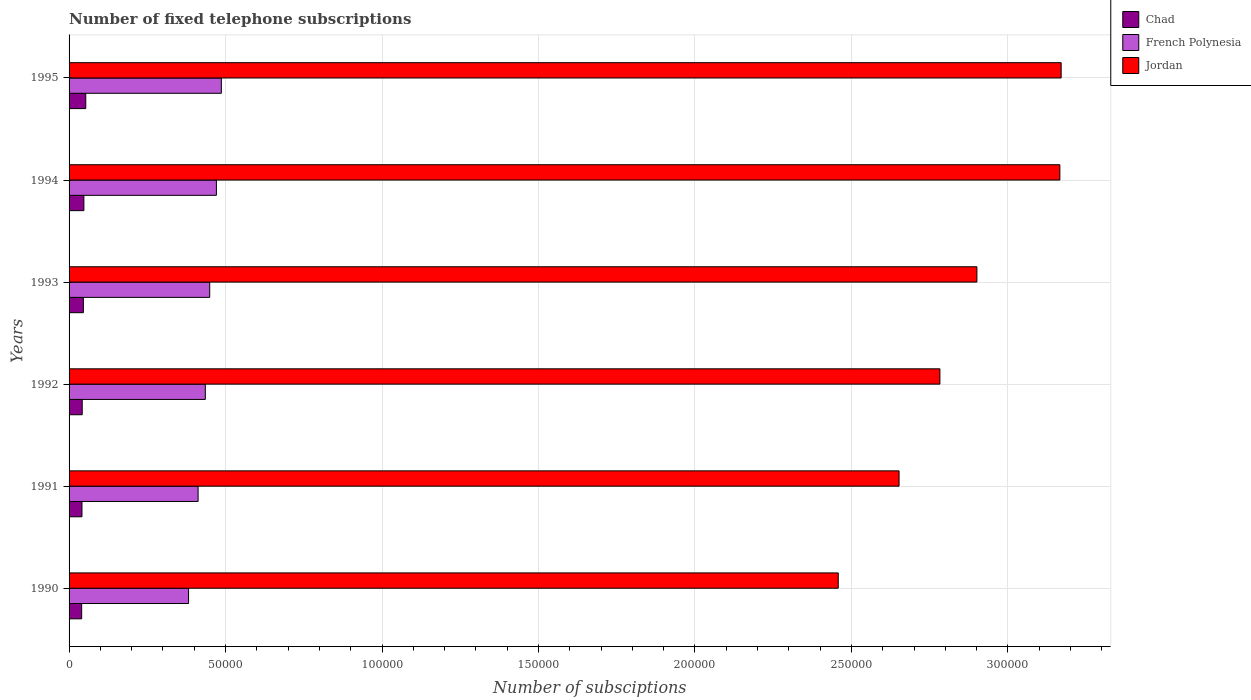Are the number of bars per tick equal to the number of legend labels?
Offer a terse response. Yes. In how many cases, is the number of bars for a given year not equal to the number of legend labels?
Your answer should be very brief. 0. What is the number of fixed telephone subscriptions in Jordan in 1991?
Your answer should be very brief. 2.65e+05. Across all years, what is the maximum number of fixed telephone subscriptions in Chad?
Keep it short and to the point. 5334. Across all years, what is the minimum number of fixed telephone subscriptions in French Polynesia?
Give a very brief answer. 3.82e+04. In which year was the number of fixed telephone subscriptions in French Polynesia maximum?
Give a very brief answer. 1995. What is the total number of fixed telephone subscriptions in French Polynesia in the graph?
Ensure brevity in your answer.  2.64e+05. What is the difference between the number of fixed telephone subscriptions in French Polynesia in 1993 and that in 1994?
Make the answer very short. -2135. What is the difference between the number of fixed telephone subscriptions in Jordan in 1992 and the number of fixed telephone subscriptions in French Polynesia in 1995?
Give a very brief answer. 2.30e+05. What is the average number of fixed telephone subscriptions in French Polynesia per year?
Give a very brief answer. 4.39e+04. In the year 1995, what is the difference between the number of fixed telephone subscriptions in Chad and number of fixed telephone subscriptions in Jordan?
Your answer should be compact. -3.12e+05. What is the ratio of the number of fixed telephone subscriptions in French Polynesia in 1990 to that in 1994?
Offer a very short reply. 0.81. Is the difference between the number of fixed telephone subscriptions in Chad in 1991 and 1993 greater than the difference between the number of fixed telephone subscriptions in Jordan in 1991 and 1993?
Ensure brevity in your answer.  Yes. What is the difference between the highest and the second highest number of fixed telephone subscriptions in Chad?
Offer a very short reply. 601. What is the difference between the highest and the lowest number of fixed telephone subscriptions in Jordan?
Keep it short and to the point. 7.12e+04. In how many years, is the number of fixed telephone subscriptions in French Polynesia greater than the average number of fixed telephone subscriptions in French Polynesia taken over all years?
Ensure brevity in your answer.  3. Is the sum of the number of fixed telephone subscriptions in Chad in 1991 and 1995 greater than the maximum number of fixed telephone subscriptions in French Polynesia across all years?
Keep it short and to the point. No. What does the 3rd bar from the top in 1995 represents?
Provide a short and direct response. Chad. What does the 1st bar from the bottom in 1995 represents?
Offer a very short reply. Chad. Is it the case that in every year, the sum of the number of fixed telephone subscriptions in Chad and number of fixed telephone subscriptions in Jordan is greater than the number of fixed telephone subscriptions in French Polynesia?
Your answer should be compact. Yes. How many bars are there?
Your answer should be very brief. 18. What is the difference between two consecutive major ticks on the X-axis?
Keep it short and to the point. 5.00e+04. Does the graph contain any zero values?
Offer a very short reply. No. What is the title of the graph?
Provide a short and direct response. Number of fixed telephone subscriptions. Does "Yemen, Rep." appear as one of the legend labels in the graph?
Your response must be concise. No. What is the label or title of the X-axis?
Give a very brief answer. Number of subsciptions. What is the label or title of the Y-axis?
Provide a succinct answer. Years. What is the Number of subsciptions of Chad in 1990?
Ensure brevity in your answer.  4026. What is the Number of subsciptions in French Polynesia in 1990?
Offer a very short reply. 3.82e+04. What is the Number of subsciptions in Jordan in 1990?
Offer a terse response. 2.46e+05. What is the Number of subsciptions of Chad in 1991?
Give a very brief answer. 4121. What is the Number of subsciptions in French Polynesia in 1991?
Ensure brevity in your answer.  4.12e+04. What is the Number of subsciptions in Jordan in 1991?
Your answer should be very brief. 2.65e+05. What is the Number of subsciptions of Chad in 1992?
Offer a very short reply. 4200. What is the Number of subsciptions of French Polynesia in 1992?
Keep it short and to the point. 4.35e+04. What is the Number of subsciptions in Jordan in 1992?
Make the answer very short. 2.78e+05. What is the Number of subsciptions of Chad in 1993?
Make the answer very short. 4571. What is the Number of subsciptions of French Polynesia in 1993?
Provide a short and direct response. 4.49e+04. What is the Number of subsciptions in Jordan in 1993?
Keep it short and to the point. 2.90e+05. What is the Number of subsciptions in Chad in 1994?
Your response must be concise. 4733. What is the Number of subsciptions in French Polynesia in 1994?
Offer a terse response. 4.71e+04. What is the Number of subsciptions of Jordan in 1994?
Your answer should be very brief. 3.17e+05. What is the Number of subsciptions in Chad in 1995?
Offer a terse response. 5334. What is the Number of subsciptions of French Polynesia in 1995?
Your answer should be very brief. 4.87e+04. What is the Number of subsciptions of Jordan in 1995?
Provide a short and direct response. 3.17e+05. Across all years, what is the maximum Number of subsciptions in Chad?
Keep it short and to the point. 5334. Across all years, what is the maximum Number of subsciptions of French Polynesia?
Give a very brief answer. 4.87e+04. Across all years, what is the maximum Number of subsciptions in Jordan?
Provide a short and direct response. 3.17e+05. Across all years, what is the minimum Number of subsciptions of Chad?
Give a very brief answer. 4026. Across all years, what is the minimum Number of subsciptions in French Polynesia?
Ensure brevity in your answer.  3.82e+04. Across all years, what is the minimum Number of subsciptions in Jordan?
Your answer should be compact. 2.46e+05. What is the total Number of subsciptions in Chad in the graph?
Your response must be concise. 2.70e+04. What is the total Number of subsciptions of French Polynesia in the graph?
Ensure brevity in your answer.  2.64e+05. What is the total Number of subsciptions of Jordan in the graph?
Make the answer very short. 1.71e+06. What is the difference between the Number of subsciptions in Chad in 1990 and that in 1991?
Offer a terse response. -95. What is the difference between the Number of subsciptions in French Polynesia in 1990 and that in 1991?
Your response must be concise. -3051. What is the difference between the Number of subsciptions of Jordan in 1990 and that in 1991?
Keep it short and to the point. -1.94e+04. What is the difference between the Number of subsciptions in Chad in 1990 and that in 1992?
Keep it short and to the point. -174. What is the difference between the Number of subsciptions of French Polynesia in 1990 and that in 1992?
Provide a succinct answer. -5359. What is the difference between the Number of subsciptions of Jordan in 1990 and that in 1992?
Your answer should be very brief. -3.25e+04. What is the difference between the Number of subsciptions in Chad in 1990 and that in 1993?
Your answer should be very brief. -545. What is the difference between the Number of subsciptions of French Polynesia in 1990 and that in 1993?
Provide a succinct answer. -6763. What is the difference between the Number of subsciptions of Jordan in 1990 and that in 1993?
Offer a terse response. -4.43e+04. What is the difference between the Number of subsciptions in Chad in 1990 and that in 1994?
Provide a short and direct response. -707. What is the difference between the Number of subsciptions in French Polynesia in 1990 and that in 1994?
Provide a succinct answer. -8898. What is the difference between the Number of subsciptions in Jordan in 1990 and that in 1994?
Offer a very short reply. -7.08e+04. What is the difference between the Number of subsciptions of Chad in 1990 and that in 1995?
Your response must be concise. -1308. What is the difference between the Number of subsciptions in French Polynesia in 1990 and that in 1995?
Provide a succinct answer. -1.05e+04. What is the difference between the Number of subsciptions of Jordan in 1990 and that in 1995?
Make the answer very short. -7.12e+04. What is the difference between the Number of subsciptions in Chad in 1991 and that in 1992?
Your response must be concise. -79. What is the difference between the Number of subsciptions of French Polynesia in 1991 and that in 1992?
Offer a terse response. -2308. What is the difference between the Number of subsciptions of Jordan in 1991 and that in 1992?
Provide a succinct answer. -1.31e+04. What is the difference between the Number of subsciptions of Chad in 1991 and that in 1993?
Your answer should be compact. -450. What is the difference between the Number of subsciptions of French Polynesia in 1991 and that in 1993?
Your answer should be compact. -3712. What is the difference between the Number of subsciptions of Jordan in 1991 and that in 1993?
Give a very brief answer. -2.49e+04. What is the difference between the Number of subsciptions of Chad in 1991 and that in 1994?
Provide a short and direct response. -612. What is the difference between the Number of subsciptions of French Polynesia in 1991 and that in 1994?
Give a very brief answer. -5847. What is the difference between the Number of subsciptions in Jordan in 1991 and that in 1994?
Ensure brevity in your answer.  -5.14e+04. What is the difference between the Number of subsciptions in Chad in 1991 and that in 1995?
Offer a terse response. -1213. What is the difference between the Number of subsciptions of French Polynesia in 1991 and that in 1995?
Ensure brevity in your answer.  -7424. What is the difference between the Number of subsciptions in Jordan in 1991 and that in 1995?
Offer a very short reply. -5.18e+04. What is the difference between the Number of subsciptions in Chad in 1992 and that in 1993?
Your answer should be very brief. -371. What is the difference between the Number of subsciptions of French Polynesia in 1992 and that in 1993?
Offer a terse response. -1404. What is the difference between the Number of subsciptions in Jordan in 1992 and that in 1993?
Offer a terse response. -1.18e+04. What is the difference between the Number of subsciptions in Chad in 1992 and that in 1994?
Offer a terse response. -533. What is the difference between the Number of subsciptions in French Polynesia in 1992 and that in 1994?
Your answer should be very brief. -3539. What is the difference between the Number of subsciptions in Jordan in 1992 and that in 1994?
Provide a short and direct response. -3.83e+04. What is the difference between the Number of subsciptions in Chad in 1992 and that in 1995?
Offer a terse response. -1134. What is the difference between the Number of subsciptions in French Polynesia in 1992 and that in 1995?
Keep it short and to the point. -5116. What is the difference between the Number of subsciptions in Jordan in 1992 and that in 1995?
Give a very brief answer. -3.87e+04. What is the difference between the Number of subsciptions in Chad in 1993 and that in 1994?
Your answer should be compact. -162. What is the difference between the Number of subsciptions of French Polynesia in 1993 and that in 1994?
Your answer should be very brief. -2135. What is the difference between the Number of subsciptions of Jordan in 1993 and that in 1994?
Your response must be concise. -2.65e+04. What is the difference between the Number of subsciptions of Chad in 1993 and that in 1995?
Ensure brevity in your answer.  -763. What is the difference between the Number of subsciptions in French Polynesia in 1993 and that in 1995?
Provide a succinct answer. -3712. What is the difference between the Number of subsciptions of Jordan in 1993 and that in 1995?
Your answer should be compact. -2.69e+04. What is the difference between the Number of subsciptions of Chad in 1994 and that in 1995?
Your response must be concise. -601. What is the difference between the Number of subsciptions in French Polynesia in 1994 and that in 1995?
Provide a short and direct response. -1577. What is the difference between the Number of subsciptions in Jordan in 1994 and that in 1995?
Your answer should be compact. -414. What is the difference between the Number of subsciptions in Chad in 1990 and the Number of subsciptions in French Polynesia in 1991?
Your answer should be very brief. -3.72e+04. What is the difference between the Number of subsciptions in Chad in 1990 and the Number of subsciptions in Jordan in 1991?
Offer a very short reply. -2.61e+05. What is the difference between the Number of subsciptions of French Polynesia in 1990 and the Number of subsciptions of Jordan in 1991?
Provide a short and direct response. -2.27e+05. What is the difference between the Number of subsciptions in Chad in 1990 and the Number of subsciptions in French Polynesia in 1992?
Offer a terse response. -3.95e+04. What is the difference between the Number of subsciptions in Chad in 1990 and the Number of subsciptions in Jordan in 1992?
Make the answer very short. -2.74e+05. What is the difference between the Number of subsciptions of French Polynesia in 1990 and the Number of subsciptions of Jordan in 1992?
Provide a short and direct response. -2.40e+05. What is the difference between the Number of subsciptions of Chad in 1990 and the Number of subsciptions of French Polynesia in 1993?
Provide a short and direct response. -4.09e+04. What is the difference between the Number of subsciptions of Chad in 1990 and the Number of subsciptions of Jordan in 1993?
Your answer should be compact. -2.86e+05. What is the difference between the Number of subsciptions in French Polynesia in 1990 and the Number of subsciptions in Jordan in 1993?
Provide a short and direct response. -2.52e+05. What is the difference between the Number of subsciptions in Chad in 1990 and the Number of subsciptions in French Polynesia in 1994?
Provide a short and direct response. -4.31e+04. What is the difference between the Number of subsciptions of Chad in 1990 and the Number of subsciptions of Jordan in 1994?
Your answer should be very brief. -3.13e+05. What is the difference between the Number of subsciptions in French Polynesia in 1990 and the Number of subsciptions in Jordan in 1994?
Provide a succinct answer. -2.78e+05. What is the difference between the Number of subsciptions of Chad in 1990 and the Number of subsciptions of French Polynesia in 1995?
Make the answer very short. -4.46e+04. What is the difference between the Number of subsciptions in Chad in 1990 and the Number of subsciptions in Jordan in 1995?
Your answer should be very brief. -3.13e+05. What is the difference between the Number of subsciptions of French Polynesia in 1990 and the Number of subsciptions of Jordan in 1995?
Ensure brevity in your answer.  -2.79e+05. What is the difference between the Number of subsciptions of Chad in 1991 and the Number of subsciptions of French Polynesia in 1992?
Give a very brief answer. -3.94e+04. What is the difference between the Number of subsciptions of Chad in 1991 and the Number of subsciptions of Jordan in 1992?
Provide a succinct answer. -2.74e+05. What is the difference between the Number of subsciptions in French Polynesia in 1991 and the Number of subsciptions in Jordan in 1992?
Keep it short and to the point. -2.37e+05. What is the difference between the Number of subsciptions of Chad in 1991 and the Number of subsciptions of French Polynesia in 1993?
Offer a very short reply. -4.08e+04. What is the difference between the Number of subsciptions in Chad in 1991 and the Number of subsciptions in Jordan in 1993?
Give a very brief answer. -2.86e+05. What is the difference between the Number of subsciptions in French Polynesia in 1991 and the Number of subsciptions in Jordan in 1993?
Your answer should be very brief. -2.49e+05. What is the difference between the Number of subsciptions in Chad in 1991 and the Number of subsciptions in French Polynesia in 1994?
Provide a succinct answer. -4.30e+04. What is the difference between the Number of subsciptions of Chad in 1991 and the Number of subsciptions of Jordan in 1994?
Ensure brevity in your answer.  -3.12e+05. What is the difference between the Number of subsciptions in French Polynesia in 1991 and the Number of subsciptions in Jordan in 1994?
Your answer should be very brief. -2.75e+05. What is the difference between the Number of subsciptions in Chad in 1991 and the Number of subsciptions in French Polynesia in 1995?
Provide a succinct answer. -4.45e+04. What is the difference between the Number of subsciptions of Chad in 1991 and the Number of subsciptions of Jordan in 1995?
Your response must be concise. -3.13e+05. What is the difference between the Number of subsciptions of French Polynesia in 1991 and the Number of subsciptions of Jordan in 1995?
Your response must be concise. -2.76e+05. What is the difference between the Number of subsciptions in Chad in 1992 and the Number of subsciptions in French Polynesia in 1993?
Your answer should be compact. -4.07e+04. What is the difference between the Number of subsciptions in Chad in 1992 and the Number of subsciptions in Jordan in 1993?
Offer a very short reply. -2.86e+05. What is the difference between the Number of subsciptions of French Polynesia in 1992 and the Number of subsciptions of Jordan in 1993?
Ensure brevity in your answer.  -2.47e+05. What is the difference between the Number of subsciptions in Chad in 1992 and the Number of subsciptions in French Polynesia in 1994?
Ensure brevity in your answer.  -4.29e+04. What is the difference between the Number of subsciptions of Chad in 1992 and the Number of subsciptions of Jordan in 1994?
Give a very brief answer. -3.12e+05. What is the difference between the Number of subsciptions of French Polynesia in 1992 and the Number of subsciptions of Jordan in 1994?
Offer a terse response. -2.73e+05. What is the difference between the Number of subsciptions of Chad in 1992 and the Number of subsciptions of French Polynesia in 1995?
Offer a very short reply. -4.45e+04. What is the difference between the Number of subsciptions in Chad in 1992 and the Number of subsciptions in Jordan in 1995?
Your answer should be very brief. -3.13e+05. What is the difference between the Number of subsciptions of French Polynesia in 1992 and the Number of subsciptions of Jordan in 1995?
Provide a succinct answer. -2.73e+05. What is the difference between the Number of subsciptions in Chad in 1993 and the Number of subsciptions in French Polynesia in 1994?
Your response must be concise. -4.25e+04. What is the difference between the Number of subsciptions of Chad in 1993 and the Number of subsciptions of Jordan in 1994?
Your answer should be very brief. -3.12e+05. What is the difference between the Number of subsciptions in French Polynesia in 1993 and the Number of subsciptions in Jordan in 1994?
Keep it short and to the point. -2.72e+05. What is the difference between the Number of subsciptions of Chad in 1993 and the Number of subsciptions of French Polynesia in 1995?
Offer a terse response. -4.41e+04. What is the difference between the Number of subsciptions of Chad in 1993 and the Number of subsciptions of Jordan in 1995?
Offer a terse response. -3.12e+05. What is the difference between the Number of subsciptions of French Polynesia in 1993 and the Number of subsciptions of Jordan in 1995?
Make the answer very short. -2.72e+05. What is the difference between the Number of subsciptions in Chad in 1994 and the Number of subsciptions in French Polynesia in 1995?
Your response must be concise. -4.39e+04. What is the difference between the Number of subsciptions of Chad in 1994 and the Number of subsciptions of Jordan in 1995?
Your answer should be compact. -3.12e+05. What is the difference between the Number of subsciptions of French Polynesia in 1994 and the Number of subsciptions of Jordan in 1995?
Keep it short and to the point. -2.70e+05. What is the average Number of subsciptions in Chad per year?
Give a very brief answer. 4497.5. What is the average Number of subsciptions of French Polynesia per year?
Ensure brevity in your answer.  4.39e+04. What is the average Number of subsciptions in Jordan per year?
Ensure brevity in your answer.  2.85e+05. In the year 1990, what is the difference between the Number of subsciptions in Chad and Number of subsciptions in French Polynesia?
Ensure brevity in your answer.  -3.42e+04. In the year 1990, what is the difference between the Number of subsciptions of Chad and Number of subsciptions of Jordan?
Provide a short and direct response. -2.42e+05. In the year 1990, what is the difference between the Number of subsciptions of French Polynesia and Number of subsciptions of Jordan?
Provide a succinct answer. -2.08e+05. In the year 1991, what is the difference between the Number of subsciptions in Chad and Number of subsciptions in French Polynesia?
Offer a terse response. -3.71e+04. In the year 1991, what is the difference between the Number of subsciptions in Chad and Number of subsciptions in Jordan?
Your answer should be very brief. -2.61e+05. In the year 1991, what is the difference between the Number of subsciptions in French Polynesia and Number of subsciptions in Jordan?
Keep it short and to the point. -2.24e+05. In the year 1992, what is the difference between the Number of subsciptions of Chad and Number of subsciptions of French Polynesia?
Offer a terse response. -3.93e+04. In the year 1992, what is the difference between the Number of subsciptions of Chad and Number of subsciptions of Jordan?
Offer a very short reply. -2.74e+05. In the year 1992, what is the difference between the Number of subsciptions of French Polynesia and Number of subsciptions of Jordan?
Your response must be concise. -2.35e+05. In the year 1993, what is the difference between the Number of subsciptions of Chad and Number of subsciptions of French Polynesia?
Give a very brief answer. -4.04e+04. In the year 1993, what is the difference between the Number of subsciptions of Chad and Number of subsciptions of Jordan?
Provide a succinct answer. -2.86e+05. In the year 1993, what is the difference between the Number of subsciptions in French Polynesia and Number of subsciptions in Jordan?
Give a very brief answer. -2.45e+05. In the year 1994, what is the difference between the Number of subsciptions of Chad and Number of subsciptions of French Polynesia?
Your answer should be compact. -4.23e+04. In the year 1994, what is the difference between the Number of subsciptions of Chad and Number of subsciptions of Jordan?
Keep it short and to the point. -3.12e+05. In the year 1994, what is the difference between the Number of subsciptions in French Polynesia and Number of subsciptions in Jordan?
Keep it short and to the point. -2.70e+05. In the year 1995, what is the difference between the Number of subsciptions in Chad and Number of subsciptions in French Polynesia?
Offer a very short reply. -4.33e+04. In the year 1995, what is the difference between the Number of subsciptions in Chad and Number of subsciptions in Jordan?
Ensure brevity in your answer.  -3.12e+05. In the year 1995, what is the difference between the Number of subsciptions of French Polynesia and Number of subsciptions of Jordan?
Give a very brief answer. -2.68e+05. What is the ratio of the Number of subsciptions of Chad in 1990 to that in 1991?
Provide a succinct answer. 0.98. What is the ratio of the Number of subsciptions of French Polynesia in 1990 to that in 1991?
Make the answer very short. 0.93. What is the ratio of the Number of subsciptions in Jordan in 1990 to that in 1991?
Offer a very short reply. 0.93. What is the ratio of the Number of subsciptions in Chad in 1990 to that in 1992?
Your response must be concise. 0.96. What is the ratio of the Number of subsciptions in French Polynesia in 1990 to that in 1992?
Your response must be concise. 0.88. What is the ratio of the Number of subsciptions of Jordan in 1990 to that in 1992?
Offer a terse response. 0.88. What is the ratio of the Number of subsciptions of Chad in 1990 to that in 1993?
Your answer should be very brief. 0.88. What is the ratio of the Number of subsciptions of French Polynesia in 1990 to that in 1993?
Offer a terse response. 0.85. What is the ratio of the Number of subsciptions in Jordan in 1990 to that in 1993?
Provide a short and direct response. 0.85. What is the ratio of the Number of subsciptions in Chad in 1990 to that in 1994?
Offer a terse response. 0.85. What is the ratio of the Number of subsciptions in French Polynesia in 1990 to that in 1994?
Provide a short and direct response. 0.81. What is the ratio of the Number of subsciptions of Jordan in 1990 to that in 1994?
Your answer should be very brief. 0.78. What is the ratio of the Number of subsciptions in Chad in 1990 to that in 1995?
Ensure brevity in your answer.  0.75. What is the ratio of the Number of subsciptions in French Polynesia in 1990 to that in 1995?
Provide a succinct answer. 0.78. What is the ratio of the Number of subsciptions in Jordan in 1990 to that in 1995?
Give a very brief answer. 0.78. What is the ratio of the Number of subsciptions in Chad in 1991 to that in 1992?
Your answer should be very brief. 0.98. What is the ratio of the Number of subsciptions in French Polynesia in 1991 to that in 1992?
Your answer should be very brief. 0.95. What is the ratio of the Number of subsciptions in Jordan in 1991 to that in 1992?
Give a very brief answer. 0.95. What is the ratio of the Number of subsciptions of Chad in 1991 to that in 1993?
Ensure brevity in your answer.  0.9. What is the ratio of the Number of subsciptions in French Polynesia in 1991 to that in 1993?
Keep it short and to the point. 0.92. What is the ratio of the Number of subsciptions of Jordan in 1991 to that in 1993?
Keep it short and to the point. 0.91. What is the ratio of the Number of subsciptions in Chad in 1991 to that in 1994?
Give a very brief answer. 0.87. What is the ratio of the Number of subsciptions in French Polynesia in 1991 to that in 1994?
Your response must be concise. 0.88. What is the ratio of the Number of subsciptions of Jordan in 1991 to that in 1994?
Your answer should be compact. 0.84. What is the ratio of the Number of subsciptions in Chad in 1991 to that in 1995?
Ensure brevity in your answer.  0.77. What is the ratio of the Number of subsciptions in French Polynesia in 1991 to that in 1995?
Provide a succinct answer. 0.85. What is the ratio of the Number of subsciptions of Jordan in 1991 to that in 1995?
Provide a short and direct response. 0.84. What is the ratio of the Number of subsciptions of Chad in 1992 to that in 1993?
Provide a short and direct response. 0.92. What is the ratio of the Number of subsciptions of French Polynesia in 1992 to that in 1993?
Make the answer very short. 0.97. What is the ratio of the Number of subsciptions of Jordan in 1992 to that in 1993?
Offer a very short reply. 0.96. What is the ratio of the Number of subsciptions of Chad in 1992 to that in 1994?
Keep it short and to the point. 0.89. What is the ratio of the Number of subsciptions in French Polynesia in 1992 to that in 1994?
Offer a terse response. 0.92. What is the ratio of the Number of subsciptions in Jordan in 1992 to that in 1994?
Ensure brevity in your answer.  0.88. What is the ratio of the Number of subsciptions in Chad in 1992 to that in 1995?
Keep it short and to the point. 0.79. What is the ratio of the Number of subsciptions in French Polynesia in 1992 to that in 1995?
Offer a terse response. 0.89. What is the ratio of the Number of subsciptions in Jordan in 1992 to that in 1995?
Give a very brief answer. 0.88. What is the ratio of the Number of subsciptions of Chad in 1993 to that in 1994?
Give a very brief answer. 0.97. What is the ratio of the Number of subsciptions in French Polynesia in 1993 to that in 1994?
Your response must be concise. 0.95. What is the ratio of the Number of subsciptions in Jordan in 1993 to that in 1994?
Your answer should be very brief. 0.92. What is the ratio of the Number of subsciptions of Chad in 1993 to that in 1995?
Offer a terse response. 0.86. What is the ratio of the Number of subsciptions in French Polynesia in 1993 to that in 1995?
Provide a short and direct response. 0.92. What is the ratio of the Number of subsciptions in Jordan in 1993 to that in 1995?
Keep it short and to the point. 0.92. What is the ratio of the Number of subsciptions in Chad in 1994 to that in 1995?
Offer a terse response. 0.89. What is the ratio of the Number of subsciptions in French Polynesia in 1994 to that in 1995?
Ensure brevity in your answer.  0.97. What is the difference between the highest and the second highest Number of subsciptions of Chad?
Provide a succinct answer. 601. What is the difference between the highest and the second highest Number of subsciptions in French Polynesia?
Keep it short and to the point. 1577. What is the difference between the highest and the second highest Number of subsciptions in Jordan?
Your answer should be compact. 414. What is the difference between the highest and the lowest Number of subsciptions of Chad?
Ensure brevity in your answer.  1308. What is the difference between the highest and the lowest Number of subsciptions of French Polynesia?
Ensure brevity in your answer.  1.05e+04. What is the difference between the highest and the lowest Number of subsciptions in Jordan?
Offer a terse response. 7.12e+04. 